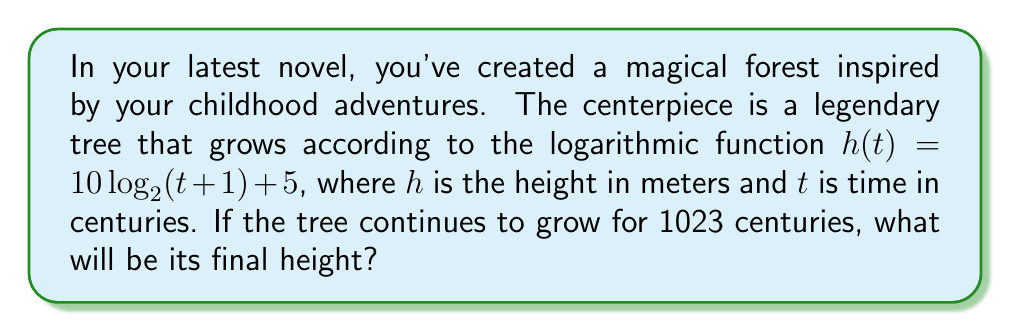Give your solution to this math problem. Let's approach this step-by-step:

1) We're given the function $h(t) = 10 \log_2(t+1) + 5$, where:
   - $h$ is the height in meters
   - $t$ is time in centuries
   - We need to find $h$ when $t = 1023$

2) Let's substitute $t = 1023$ into the function:

   $h(1023) = 10 \log_2(1023+1) + 5$

3) Simplify inside the parentheses:

   $h(1023) = 10 \log_2(1024) + 5$

4) Now, let's consider the properties of logarithms. We know that:

   $\log_2(1024) = 10$ because $2^{10} = 1024$

5) Substituting this in:

   $h(1023) = 10 \cdot 10 + 5$

6) Simplify:

   $h(1023) = 100 + 5 = 105$

Therefore, after 1023 centuries, the legendary tree will be 105 meters tall.
Answer: 105 meters 